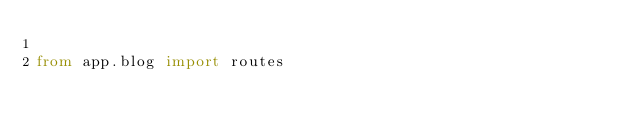Convert code to text. <code><loc_0><loc_0><loc_500><loc_500><_Python_>
from app.blog import routes</code> 